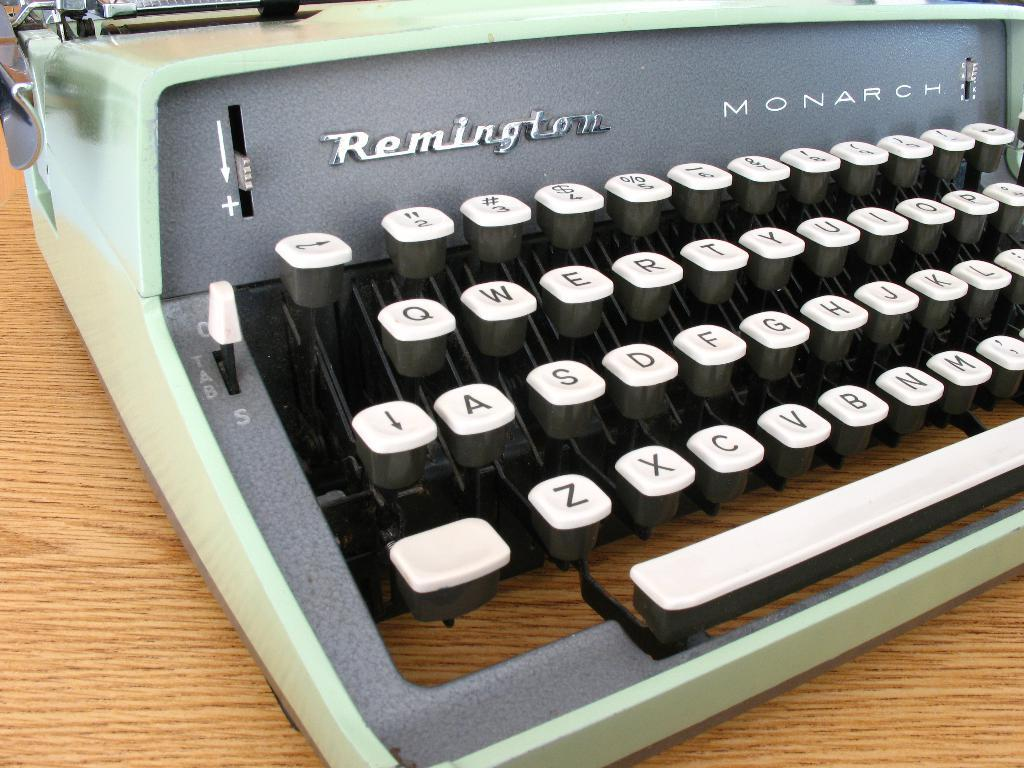<image>
Describe the image concisely. An old typewriter called the Remington Monarch sits on a wood table. 